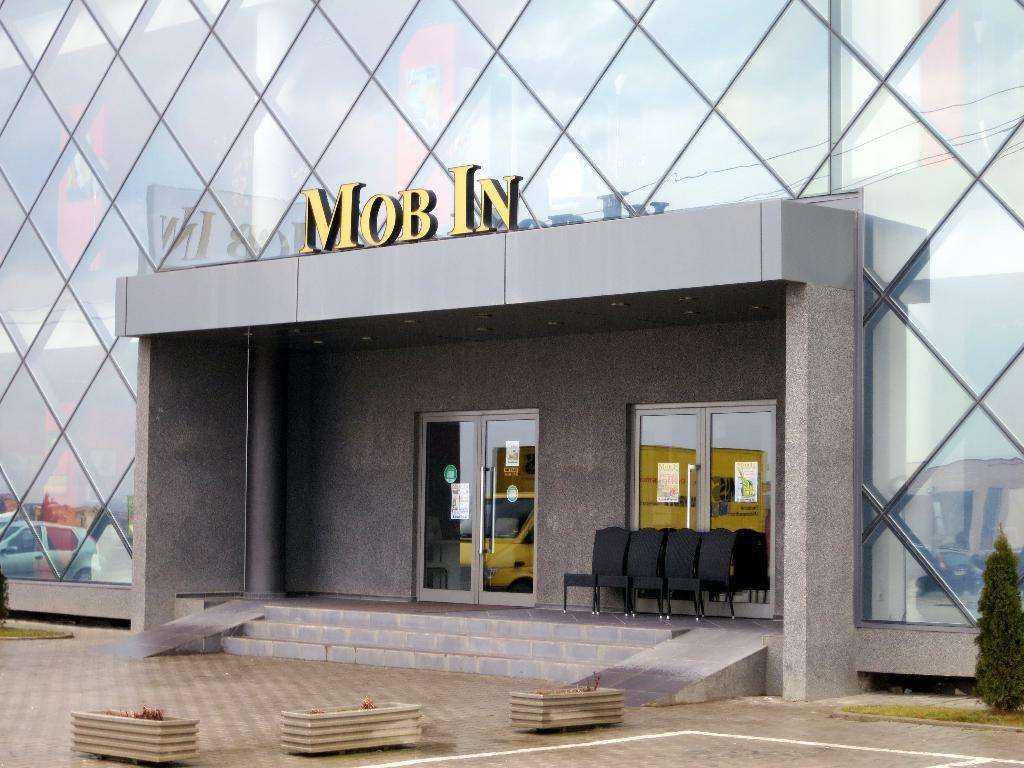What type of building is depicted in the image? There is a glass building in the image. What feature of the building is made of glass? There are glass doors in the image. What architectural element can be seen in the image? There are stairs in the image. What type of furniture is present in the image? There are chairs in the image. What type of greenery is visible in the image? There are plants in the image. What is attached to the glass in the image? There are posters attached to the glass in the image. What type of pet can be seen playing with a glove in the image? There is no pet or glove present in the image. 